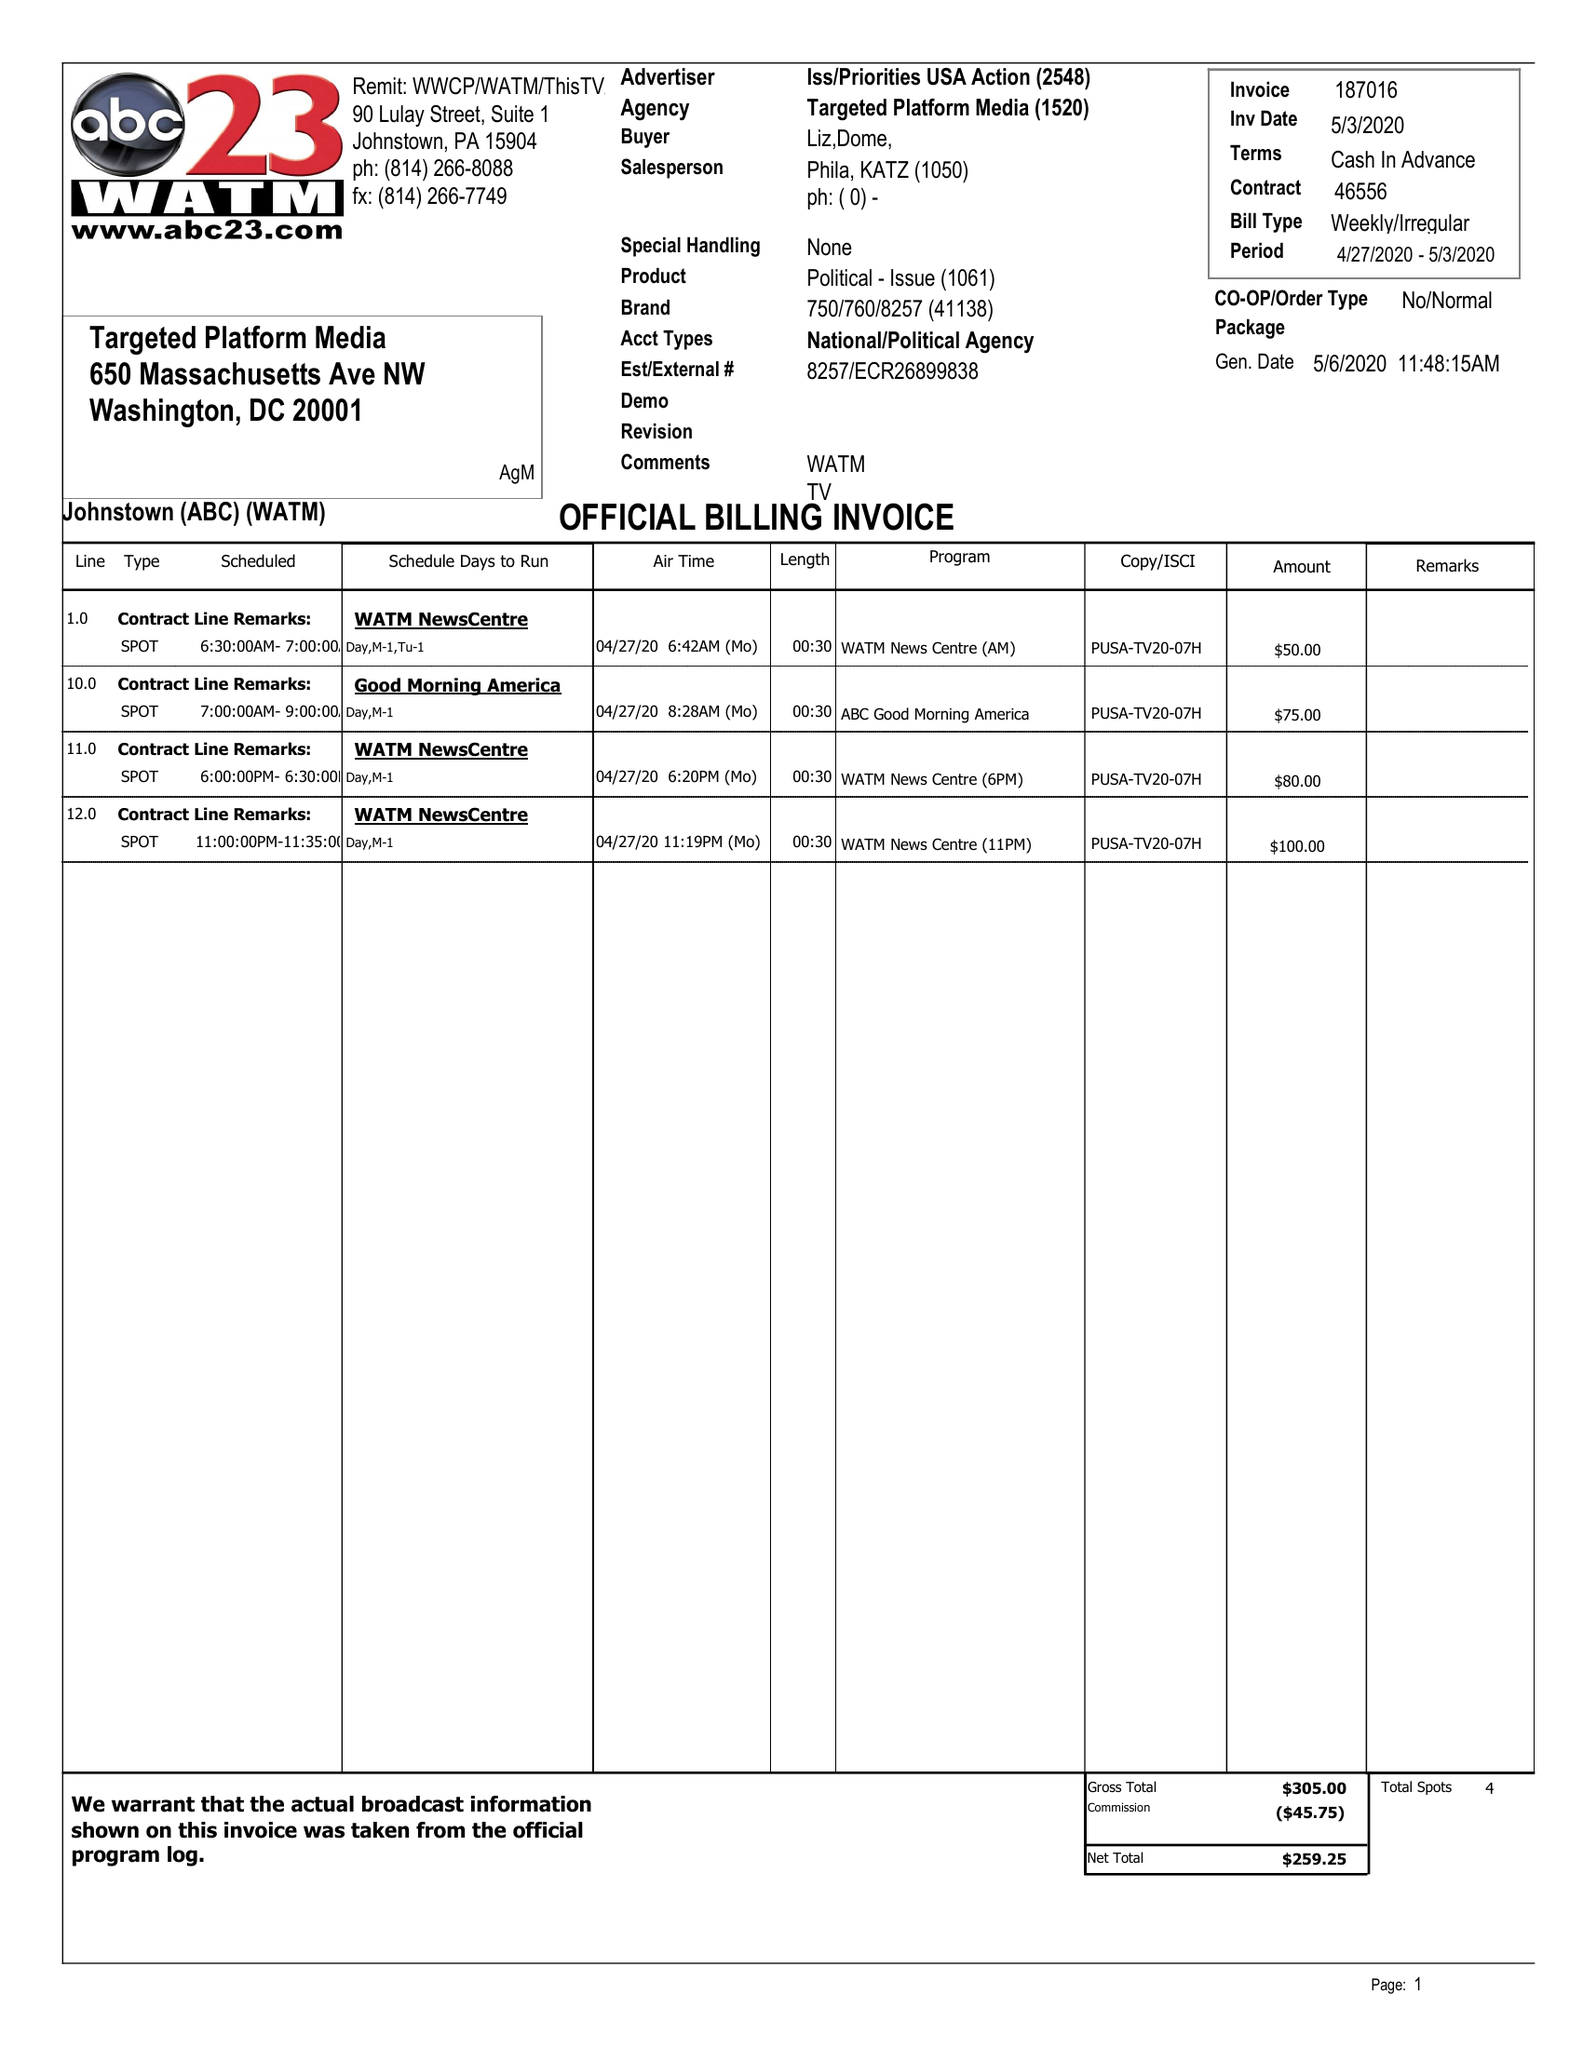What is the value for the gross_amount?
Answer the question using a single word or phrase. 24260.00 